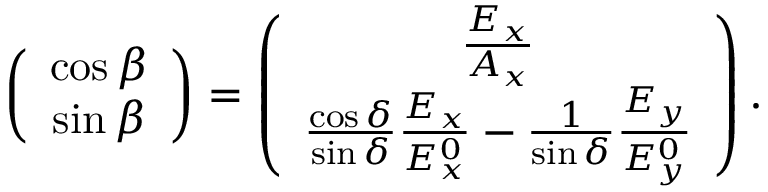Convert formula to latex. <formula><loc_0><loc_0><loc_500><loc_500>\begin{array} { r } { \left ( \begin{array} { c } { \cos \beta } \\ { \sin \beta } \end{array} \right ) = \left ( \begin{array} { c } { \frac { E _ { x } } { A _ { x } } } \\ { \frac { \cos \delta } { \sin \delta } \frac { E _ { x } } { E _ { x } ^ { 0 } } - \frac { 1 } { \sin \delta } \frac { E _ { y } } { E _ { y } ^ { 0 } } } \end{array} \right ) . } \end{array}</formula> 